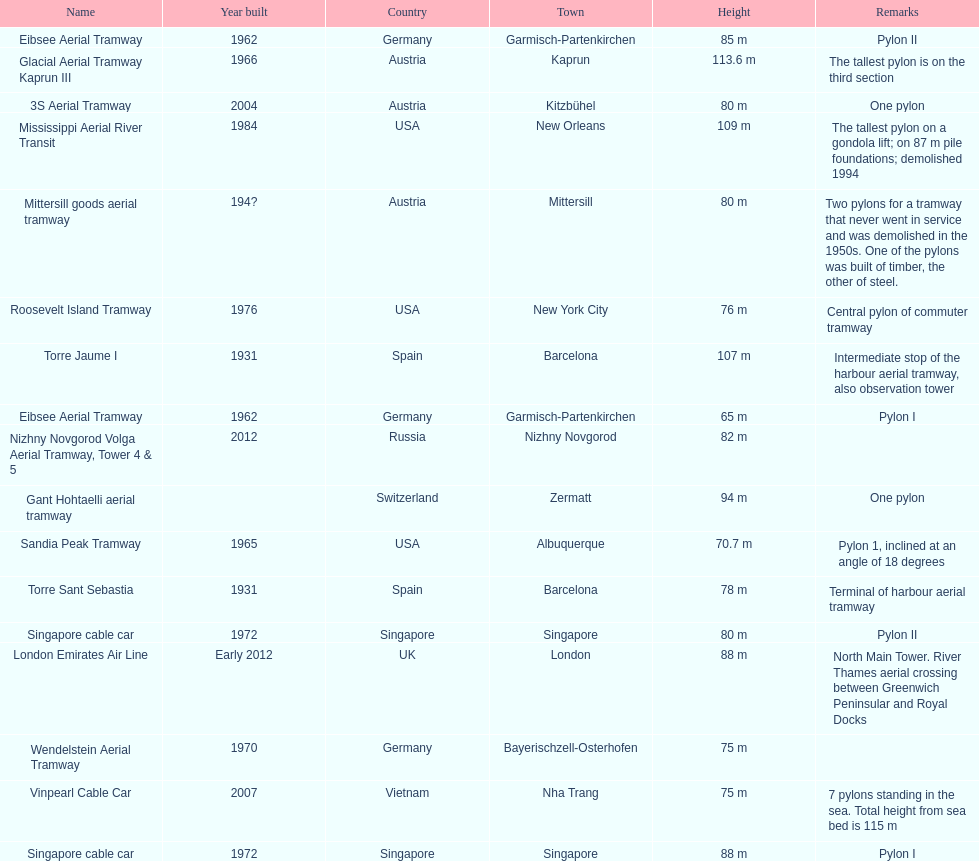How many pylons are in austria? 3. 